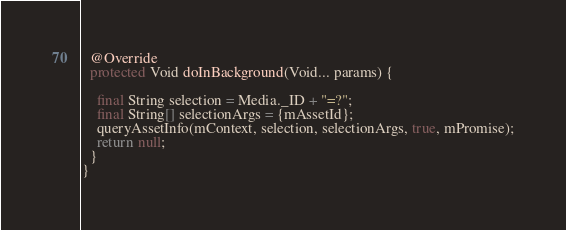Convert code to text. <code><loc_0><loc_0><loc_500><loc_500><_Java_>
  @Override
  protected Void doInBackground(Void... params) {

    final String selection = Media._ID + "=?";
    final String[] selectionArgs = {mAssetId};
    queryAssetInfo(mContext, selection, selectionArgs, true, mPromise);
    return null;
  }
}
</code> 